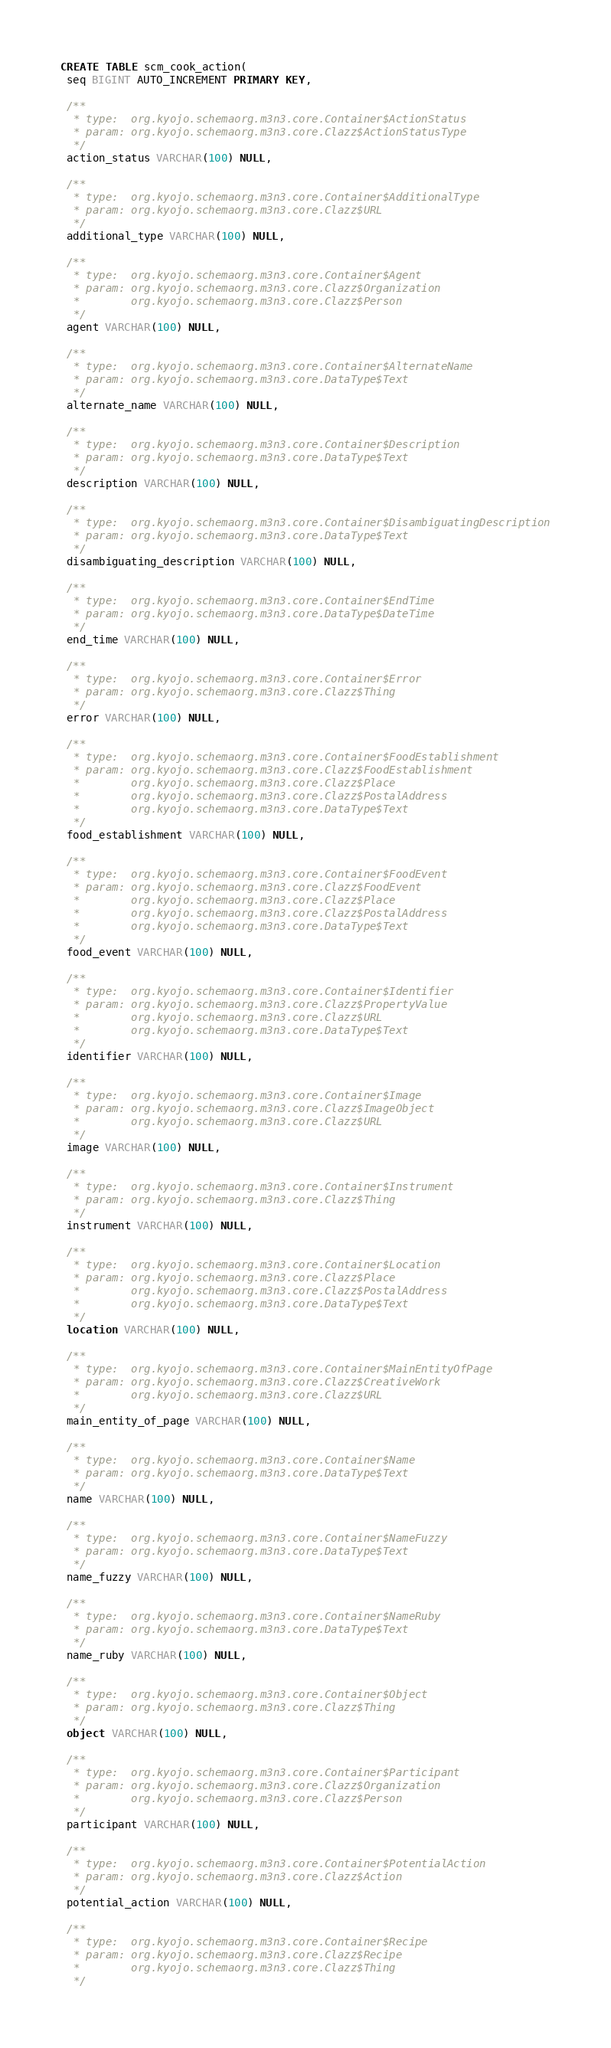Convert code to text. <code><loc_0><loc_0><loc_500><loc_500><_SQL_>CREATE TABLE scm_cook_action(
 seq BIGINT AUTO_INCREMENT PRIMARY KEY,

 /**
  * type:  org.kyojo.schemaorg.m3n3.core.Container$ActionStatus
  * param: org.kyojo.schemaorg.m3n3.core.Clazz$ActionStatusType
  */
 action_status VARCHAR(100) NULL,

 /**
  * type:  org.kyojo.schemaorg.m3n3.core.Container$AdditionalType
  * param: org.kyojo.schemaorg.m3n3.core.Clazz$URL
  */
 additional_type VARCHAR(100) NULL,

 /**
  * type:  org.kyojo.schemaorg.m3n3.core.Container$Agent
  * param: org.kyojo.schemaorg.m3n3.core.Clazz$Organization
  *        org.kyojo.schemaorg.m3n3.core.Clazz$Person
  */
 agent VARCHAR(100) NULL,

 /**
  * type:  org.kyojo.schemaorg.m3n3.core.Container$AlternateName
  * param: org.kyojo.schemaorg.m3n3.core.DataType$Text
  */
 alternate_name VARCHAR(100) NULL,

 /**
  * type:  org.kyojo.schemaorg.m3n3.core.Container$Description
  * param: org.kyojo.schemaorg.m3n3.core.DataType$Text
  */
 description VARCHAR(100) NULL,

 /**
  * type:  org.kyojo.schemaorg.m3n3.core.Container$DisambiguatingDescription
  * param: org.kyojo.schemaorg.m3n3.core.DataType$Text
  */
 disambiguating_description VARCHAR(100) NULL,

 /**
  * type:  org.kyojo.schemaorg.m3n3.core.Container$EndTime
  * param: org.kyojo.schemaorg.m3n3.core.DataType$DateTime
  */
 end_time VARCHAR(100) NULL,

 /**
  * type:  org.kyojo.schemaorg.m3n3.core.Container$Error
  * param: org.kyojo.schemaorg.m3n3.core.Clazz$Thing
  */
 error VARCHAR(100) NULL,

 /**
  * type:  org.kyojo.schemaorg.m3n3.core.Container$FoodEstablishment
  * param: org.kyojo.schemaorg.m3n3.core.Clazz$FoodEstablishment
  *        org.kyojo.schemaorg.m3n3.core.Clazz$Place
  *        org.kyojo.schemaorg.m3n3.core.Clazz$PostalAddress
  *        org.kyojo.schemaorg.m3n3.core.DataType$Text
  */
 food_establishment VARCHAR(100) NULL,

 /**
  * type:  org.kyojo.schemaorg.m3n3.core.Container$FoodEvent
  * param: org.kyojo.schemaorg.m3n3.core.Clazz$FoodEvent
  *        org.kyojo.schemaorg.m3n3.core.Clazz$Place
  *        org.kyojo.schemaorg.m3n3.core.Clazz$PostalAddress
  *        org.kyojo.schemaorg.m3n3.core.DataType$Text
  */
 food_event VARCHAR(100) NULL,

 /**
  * type:  org.kyojo.schemaorg.m3n3.core.Container$Identifier
  * param: org.kyojo.schemaorg.m3n3.core.Clazz$PropertyValue
  *        org.kyojo.schemaorg.m3n3.core.Clazz$URL
  *        org.kyojo.schemaorg.m3n3.core.DataType$Text
  */
 identifier VARCHAR(100) NULL,

 /**
  * type:  org.kyojo.schemaorg.m3n3.core.Container$Image
  * param: org.kyojo.schemaorg.m3n3.core.Clazz$ImageObject
  *        org.kyojo.schemaorg.m3n3.core.Clazz$URL
  */
 image VARCHAR(100) NULL,

 /**
  * type:  org.kyojo.schemaorg.m3n3.core.Container$Instrument
  * param: org.kyojo.schemaorg.m3n3.core.Clazz$Thing
  */
 instrument VARCHAR(100) NULL,

 /**
  * type:  org.kyojo.schemaorg.m3n3.core.Container$Location
  * param: org.kyojo.schemaorg.m3n3.core.Clazz$Place
  *        org.kyojo.schemaorg.m3n3.core.Clazz$PostalAddress
  *        org.kyojo.schemaorg.m3n3.core.DataType$Text
  */
 location VARCHAR(100) NULL,

 /**
  * type:  org.kyojo.schemaorg.m3n3.core.Container$MainEntityOfPage
  * param: org.kyojo.schemaorg.m3n3.core.Clazz$CreativeWork
  *        org.kyojo.schemaorg.m3n3.core.Clazz$URL
  */
 main_entity_of_page VARCHAR(100) NULL,

 /**
  * type:  org.kyojo.schemaorg.m3n3.core.Container$Name
  * param: org.kyojo.schemaorg.m3n3.core.DataType$Text
  */
 name VARCHAR(100) NULL,

 /**
  * type:  org.kyojo.schemaorg.m3n3.core.Container$NameFuzzy
  * param: org.kyojo.schemaorg.m3n3.core.DataType$Text
  */
 name_fuzzy VARCHAR(100) NULL,

 /**
  * type:  org.kyojo.schemaorg.m3n3.core.Container$NameRuby
  * param: org.kyojo.schemaorg.m3n3.core.DataType$Text
  */
 name_ruby VARCHAR(100) NULL,

 /**
  * type:  org.kyojo.schemaorg.m3n3.core.Container$Object
  * param: org.kyojo.schemaorg.m3n3.core.Clazz$Thing
  */
 object VARCHAR(100) NULL,

 /**
  * type:  org.kyojo.schemaorg.m3n3.core.Container$Participant
  * param: org.kyojo.schemaorg.m3n3.core.Clazz$Organization
  *        org.kyojo.schemaorg.m3n3.core.Clazz$Person
  */
 participant VARCHAR(100) NULL,

 /**
  * type:  org.kyojo.schemaorg.m3n3.core.Container$PotentialAction
  * param: org.kyojo.schemaorg.m3n3.core.Clazz$Action
  */
 potential_action VARCHAR(100) NULL,

 /**
  * type:  org.kyojo.schemaorg.m3n3.core.Container$Recipe
  * param: org.kyojo.schemaorg.m3n3.core.Clazz$Recipe
  *        org.kyojo.schemaorg.m3n3.core.Clazz$Thing
  */</code> 